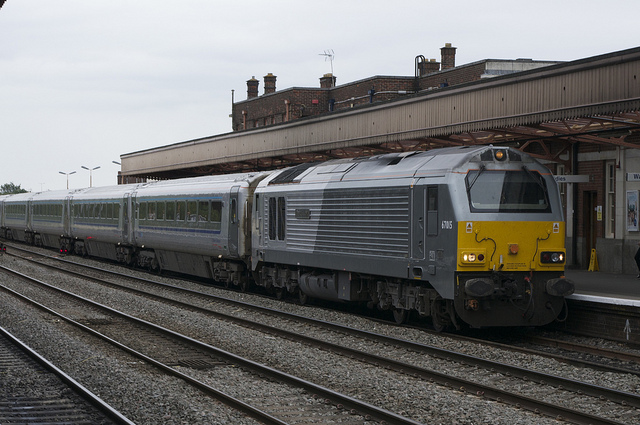How many train tracks do you see? From the perspective presented in the image, there appear to be a total of three visible train tracks; one where the train is currently located and two additional parallel tracks alongside it. However, it's possible that there are more tracks outside the viewable area of the photo. 